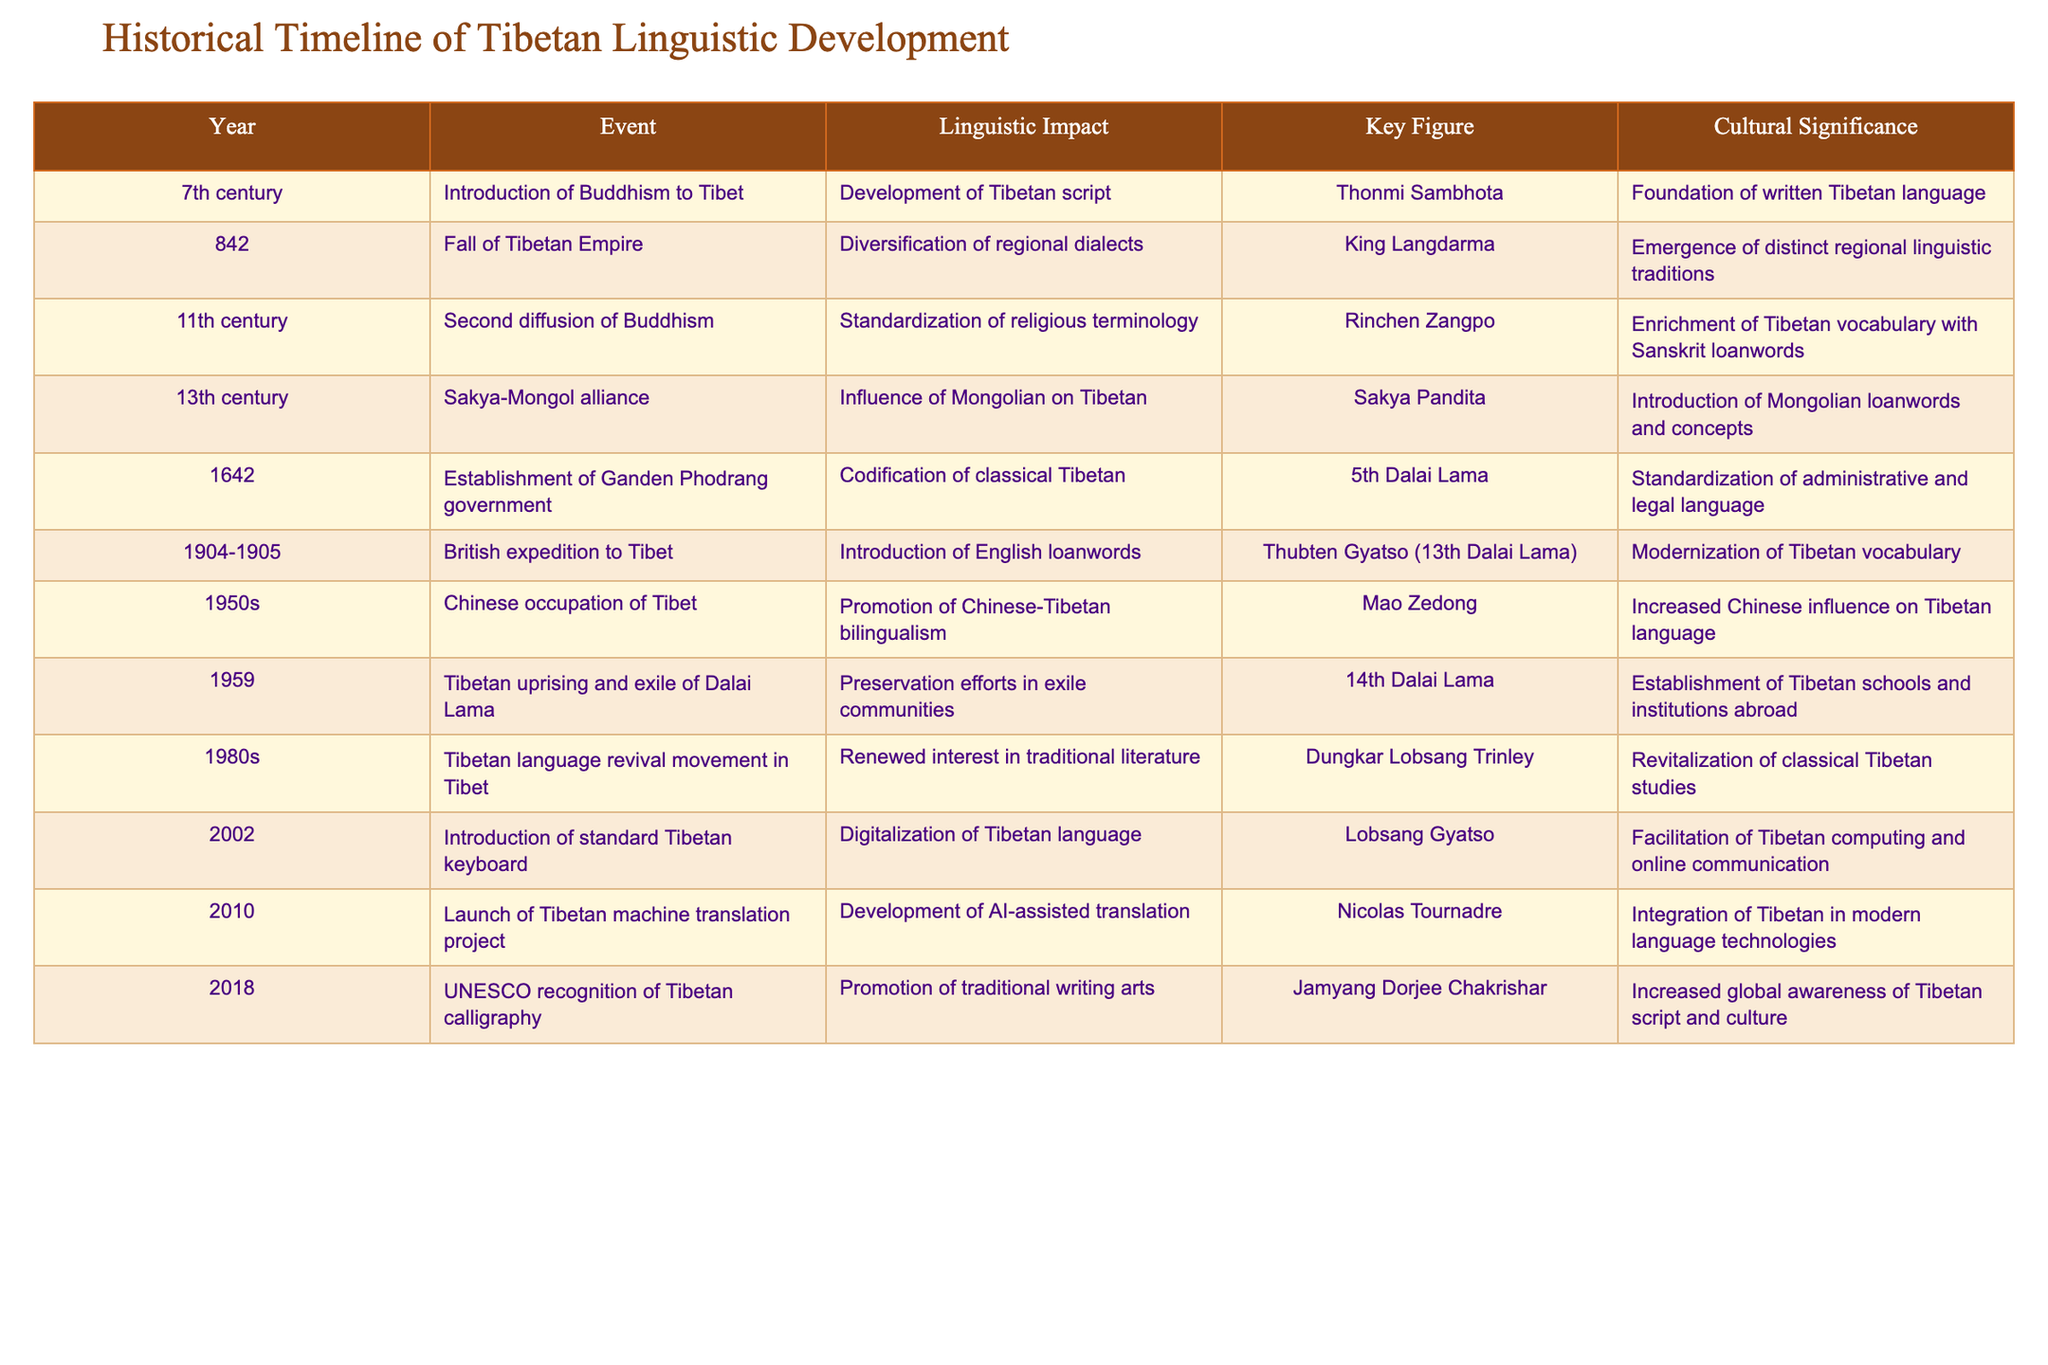What year did the introduction of Buddhism to Tibet occur? The table lists the event 'Introduction of Buddhism to Tibet' with the year mentioned as '7th century'.
Answer: 7th century Who was the key figure associated with the establishment of the Ganden Phodrang government? According to the table, the key figure for the establishment of the Ganden Phodrang government in 1642 is listed as the '5th Dalai Lama'.
Answer: 5th Dalai Lama Which event marks the beginning of the preservation efforts in Tibetan exile communities? The table indicates that the event 'Tibetan uprising and exile of Dalai Lama' in 1959 is linked to preservation efforts in exile communities.
Answer: 1959 What linguistic impact did the second diffusion of Buddhism have? The table states that the linguistic impact of the second diffusion of Buddhism in the 11th century was the 'Standardization of religious terminology'.
Answer: Standardization of religious terminology How many centuries are represented in the timeline provided? The table provides events from various centuries, specifically the 7th, 11th, 13th, 17th, 20th, and 21st centuries, which counts to a total of 6 centuries.
Answer: 6 centuries Is the introduction of English loanwords noted during the Chinese occupation of Tibet? The table states that the introduction of English loanwords occurred during the 'British expedition to Tibet' in 1904-1905, not specifically noted during the Chinese occupation.
Answer: No What was the cultural significance of the year 2002? The table indicates that the cultural significance of the year 2002 is related to the 'Introduction of standard Tibetan keyboard' which facilitated Tibetan computing and online communication.
Answer: Facilitation of Tibetan computing How did the Mongolian influence Tibetan language according to the historical events listed? The table shows that in the 13th century, the Sakya-Mongol alliance had the impact of introducing Mongolian loanwords and concepts, according to the event 'Influence of Mongolian on Tibetan'.
Answer: Introduction of Mongolian loanwords Which event in the timeline led to the enrichment of the Tibetan vocabulary with Sanskrit loanwords? The event 'Second diffusion of Buddhism' in the 11th century is noted for the enrichment of Tibetan vocabulary with Sanskrit loanwords.
Answer: Second diffusion of Buddhism What was the linguistic impact of the fall of the Tibetan Empire? The table describes the linguistic impact of the fall of the Tibetan Empire in 842 as the 'Diversification of regional dialects'.
Answer: Diversification of regional dialects Calculate the time span between the introduction of Buddhism to Tibet and the launch of the Tibetan machine translation project. The introduction of Buddhism occurred in the 7th century (approx. 600 AD) and the machine translation project was launched in 2010. The time span is roughly 1410 years.
Answer: 1410 years 